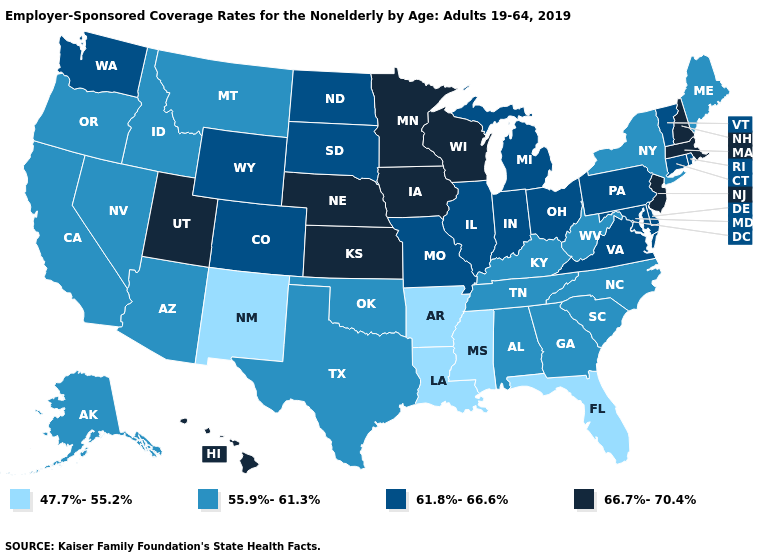What is the highest value in the USA?
Give a very brief answer. 66.7%-70.4%. What is the highest value in the USA?
Answer briefly. 66.7%-70.4%. Name the states that have a value in the range 61.8%-66.6%?
Give a very brief answer. Colorado, Connecticut, Delaware, Illinois, Indiana, Maryland, Michigan, Missouri, North Dakota, Ohio, Pennsylvania, Rhode Island, South Dakota, Vermont, Virginia, Washington, Wyoming. What is the highest value in states that border Arkansas?
Short answer required. 61.8%-66.6%. Does Massachusetts have the highest value in the USA?
Keep it brief. Yes. What is the value of Nevada?
Concise answer only. 55.9%-61.3%. Which states have the lowest value in the South?
Answer briefly. Arkansas, Florida, Louisiana, Mississippi. Name the states that have a value in the range 47.7%-55.2%?
Short answer required. Arkansas, Florida, Louisiana, Mississippi, New Mexico. Does Minnesota have the lowest value in the USA?
Short answer required. No. Among the states that border Colorado , which have the highest value?
Quick response, please. Kansas, Nebraska, Utah. Does New Jersey have the highest value in the Northeast?
Be succinct. Yes. Name the states that have a value in the range 66.7%-70.4%?
Short answer required. Hawaii, Iowa, Kansas, Massachusetts, Minnesota, Nebraska, New Hampshire, New Jersey, Utah, Wisconsin. What is the value of South Carolina?
Quick response, please. 55.9%-61.3%. What is the highest value in states that border Idaho?
Answer briefly. 66.7%-70.4%. What is the value of Alabama?
Answer briefly. 55.9%-61.3%. 